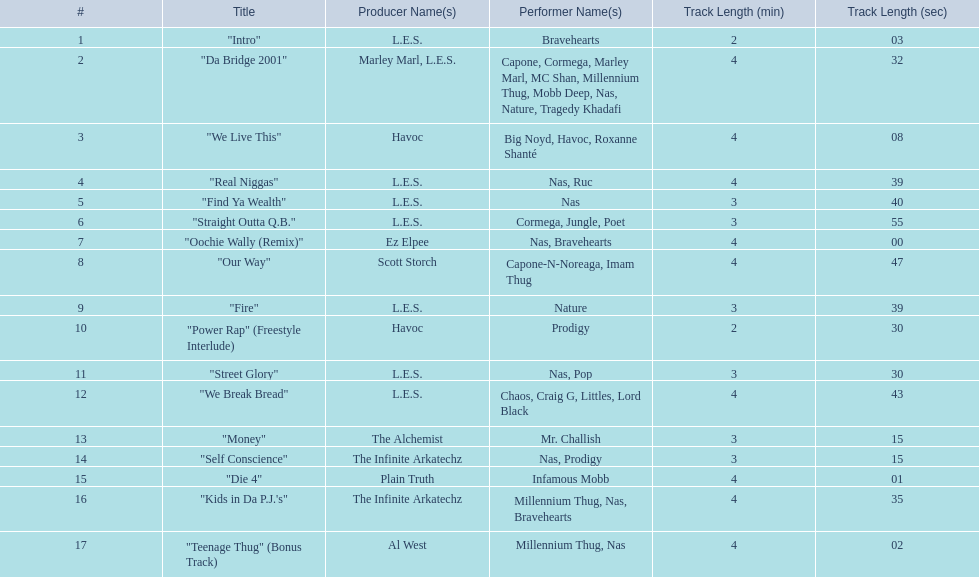What are the track times on the nas & ill will records presents qb's finest album? 2:03, 4:32, 4:08, 4:39, 3:40, 3:55, 4:00, 4:47, 3:39, 2:30, 3:30, 4:43, 3:15, 3:15, 4:01, 4:35, 4:02. Of those which is the longest? 4:47. 